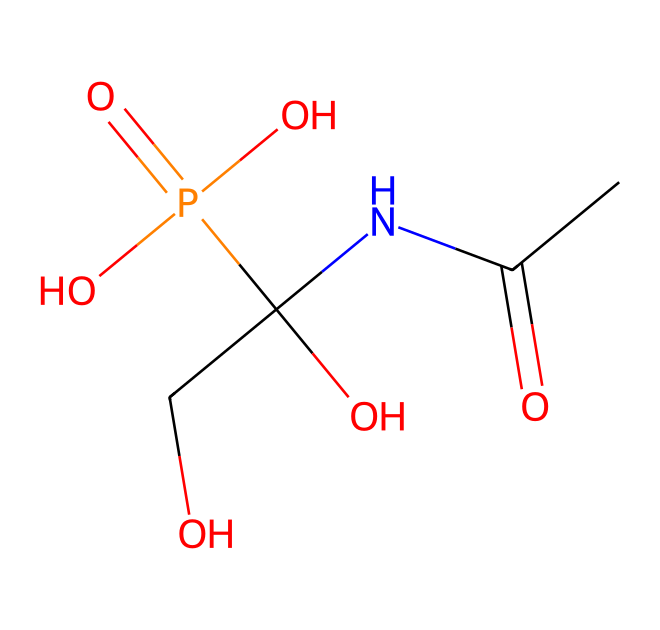What is the primary functional group present in glyphosate? Glyphosate contains a carboxylic acid functional group, which is identified by the presence of the carbon atom bonded to a hydroxyl group (-OH) and a double-bonded oxygen (C=O).
Answer: carboxylic acid How many carbon atoms are in glyphosate? By examining the SMILES representation, we can count the carbon atoms, which are indicated by the letter 'C.' In this case, there are three carbon atoms.
Answer: three What is the significance of the nitrogen atom in glyphosate's structure? The nitrogen atom contributes to the amino group present in glyphosate, which is critical for its herbicidal activity and mechanism of action, facilitating the uptake of the herbicide by plants.
Answer: amino group How many total oxygen atoms are present in glyphosate? The SMILES representation includes oxygen atoms represented by 'O.' By counting the number of 'O's, we find there are five oxygen atoms in glyphosate.
Answer: five Does glyphosate contain any phosphorus atoms? Yes, glyphosate includes a phosphorus atom, which is indicated by 'P' in the SMILES structure and is part of the phosphate group contributing to its solubility and reactivity.
Answer: yes What type of herbicide is glyphosate classified as? Glyphosate is classified as a non-selective herbicide, meaning it can kill a wide range of plants, which is linked to its mechanism that affects amino acid synthesis in plants.
Answer: non-selective herbicide 